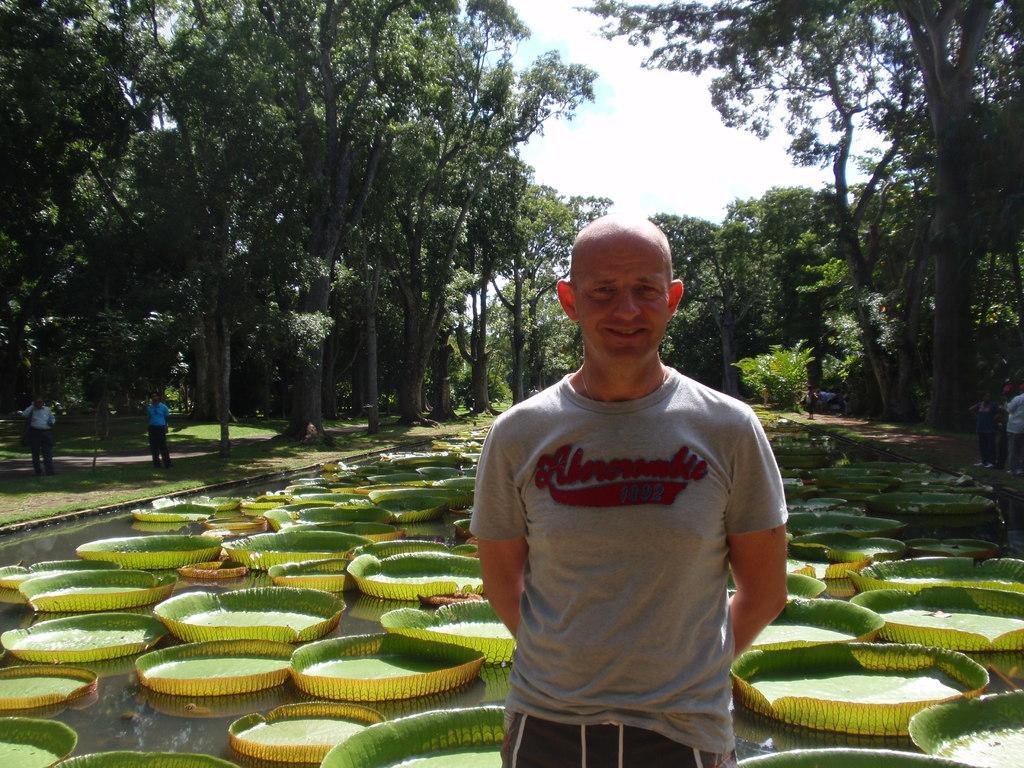Please provide a concise description of this image. Here is the man standing and smiling. He wore a T-shirt and short. These are the trees with branches and leaves. I can see few people standing. This looks like a pond. These are the kind of flowering plants named as victoria amazonica, which are floating on the water. 